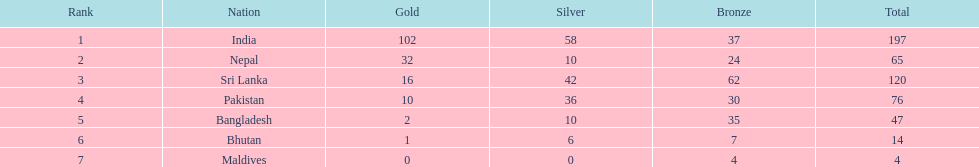What are the total number of bronze medals sri lanka have earned? 62. 